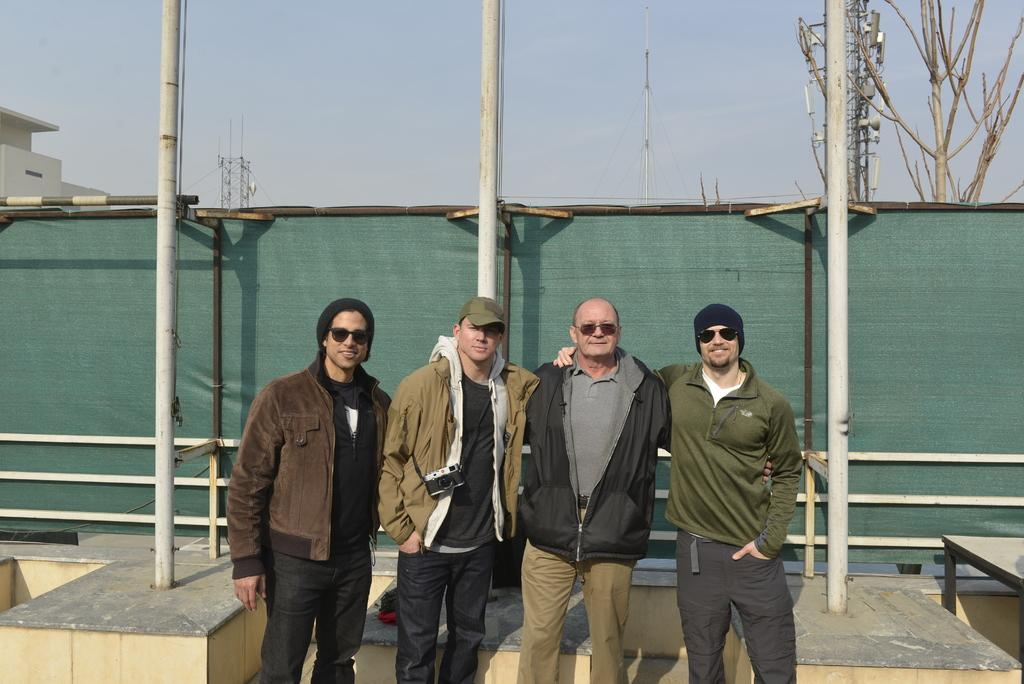How many people are standing on the path in the image? There are four people standing on the path in the image. What other structures can be seen in the image? There are poles and electric towers in the image. What type of vegetation is present in the image? There is a tree in the image. What type of building is visible in the image? There is a house in the image. What is visible at the top of the image? The sky is visible in the image. Where are the cattle grazing in the image? There are no cattle present in the image. What type of art can be seen hanging on the walls of the house in the image? There is no information about art or the interior of the house in the image. 